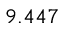Convert formula to latex. <formula><loc_0><loc_0><loc_500><loc_500>9 . 4 4 7</formula> 